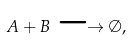<formula> <loc_0><loc_0><loc_500><loc_500>A + B \longrightarrow \emptyset ,</formula> 